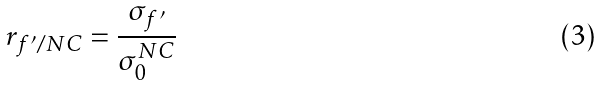<formula> <loc_0><loc_0><loc_500><loc_500>r _ { f ^ { \prime } / N C } = \frac { \sigma _ { f ^ { \prime } } } { \sigma ^ { N C } _ { 0 } }</formula> 